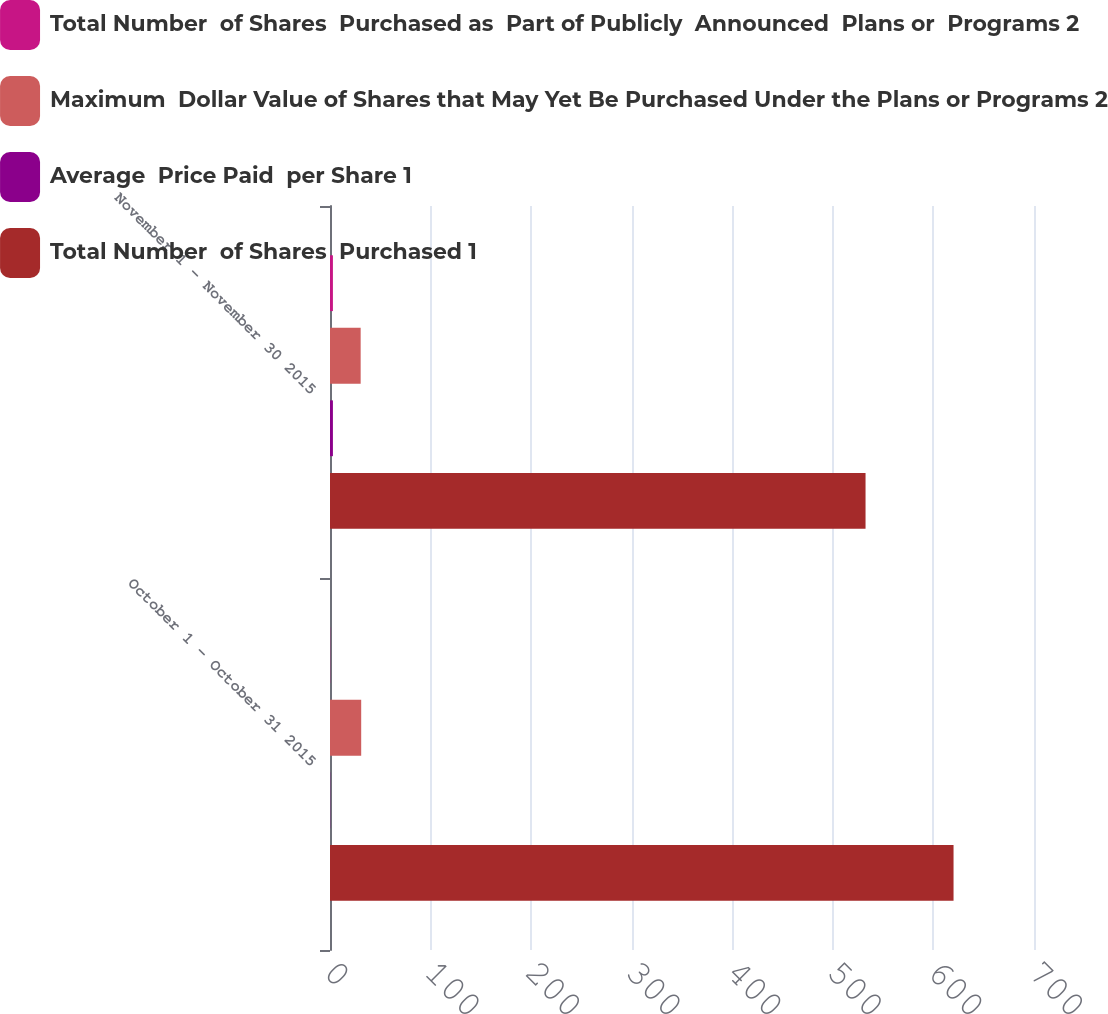Convert chart to OTSL. <chart><loc_0><loc_0><loc_500><loc_500><stacked_bar_chart><ecel><fcel>October 1 - October 31 2015<fcel>November 1 - November 30 2015<nl><fcel>Total Number  of Shares  Purchased as  Part of Publicly  Announced  Plans or  Programs 2<fcel>0.2<fcel>2.9<nl><fcel>Maximum  Dollar Value of Shares that May Yet Be Purchased Under the Plans or Programs 2<fcel>31.02<fcel>30.49<nl><fcel>Average  Price Paid  per Share 1<fcel>0.2<fcel>2.9<nl><fcel>Total Number  of Shares  Purchased 1<fcel>620<fcel>532.5<nl></chart> 